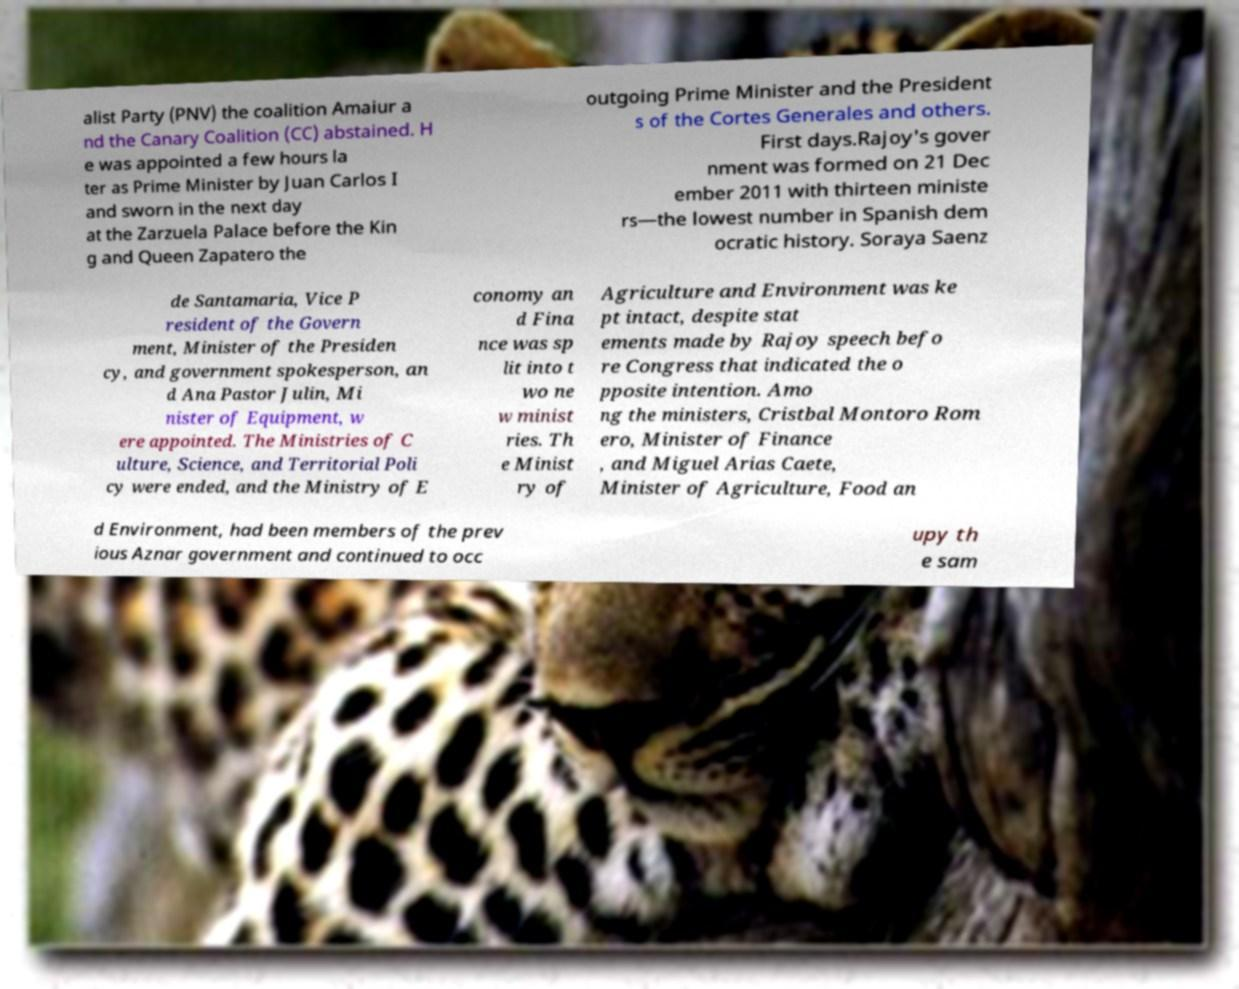Could you extract and type out the text from this image? alist Party (PNV) the coalition Amaiur a nd the Canary Coalition (CC) abstained. H e was appointed a few hours la ter as Prime Minister by Juan Carlos I and sworn in the next day at the Zarzuela Palace before the Kin g and Queen Zapatero the outgoing Prime Minister and the President s of the Cortes Generales and others. First days.Rajoy's gover nment was formed on 21 Dec ember 2011 with thirteen ministe rs—the lowest number in Spanish dem ocratic history. Soraya Saenz de Santamaria, Vice P resident of the Govern ment, Minister of the Presiden cy, and government spokesperson, an d Ana Pastor Julin, Mi nister of Equipment, w ere appointed. The Ministries of C ulture, Science, and Territorial Poli cy were ended, and the Ministry of E conomy an d Fina nce was sp lit into t wo ne w minist ries. Th e Minist ry of Agriculture and Environment was ke pt intact, despite stat ements made by Rajoy speech befo re Congress that indicated the o pposite intention. Amo ng the ministers, Cristbal Montoro Rom ero, Minister of Finance , and Miguel Arias Caete, Minister of Agriculture, Food an d Environment, had been members of the prev ious Aznar government and continued to occ upy th e sam 